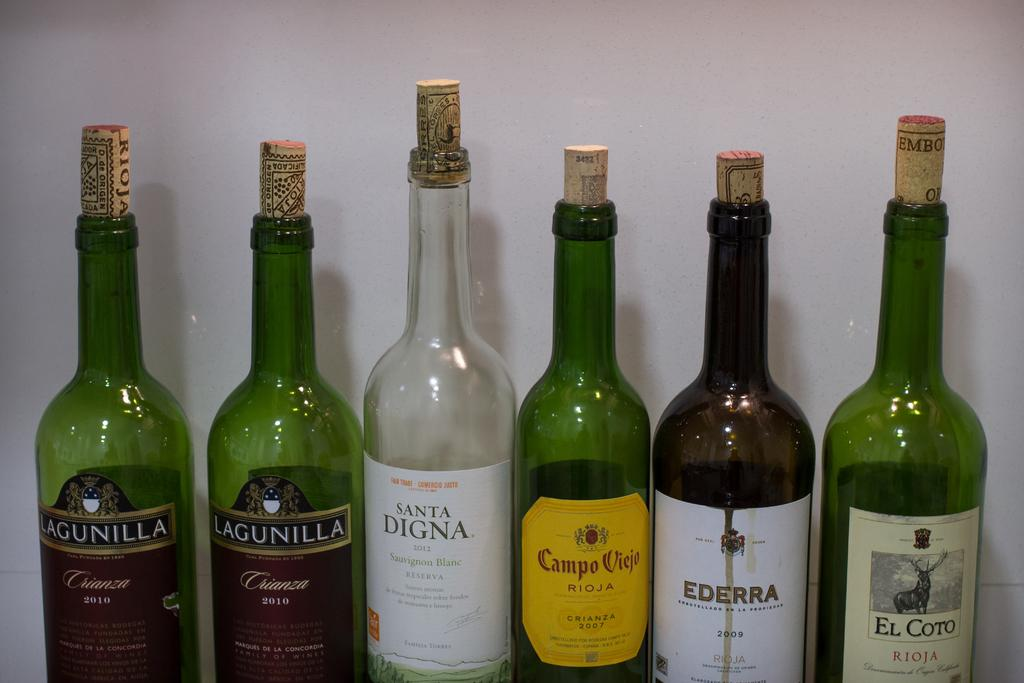<image>
Render a clear and concise summary of the photo. A row of alcohol bottles contains brands like Lagunilla and El Coto. 